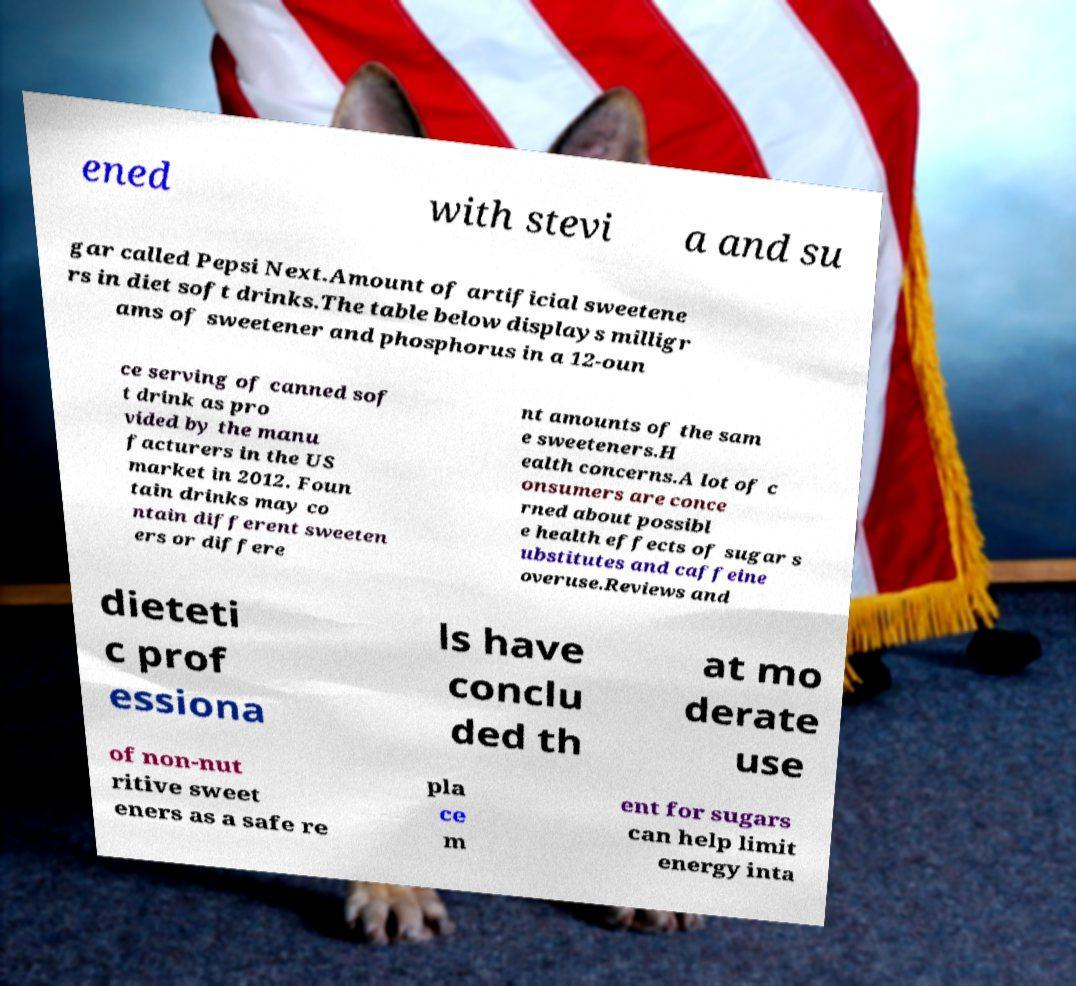Please identify and transcribe the text found in this image. ened with stevi a and su gar called Pepsi Next.Amount of artificial sweetene rs in diet soft drinks.The table below displays milligr ams of sweetener and phosphorus in a 12-oun ce serving of canned sof t drink as pro vided by the manu facturers in the US market in 2012. Foun tain drinks may co ntain different sweeten ers or differe nt amounts of the sam e sweeteners.H ealth concerns.A lot of c onsumers are conce rned about possibl e health effects of sugar s ubstitutes and caffeine overuse.Reviews and dieteti c prof essiona ls have conclu ded th at mo derate use of non-nut ritive sweet eners as a safe re pla ce m ent for sugars can help limit energy inta 